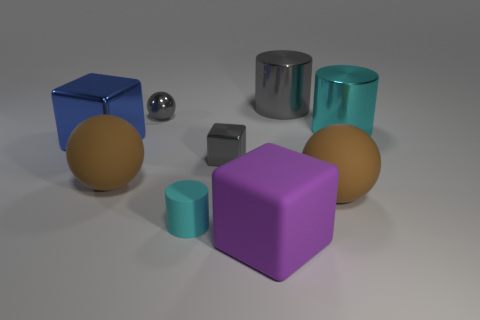What number of objects are small gray shiny objects in front of the big blue object or tiny purple shiny cubes?
Provide a short and direct response. 1. Does the large object behind the cyan metallic object have the same material as the large cyan object?
Give a very brief answer. Yes. Is the shape of the big gray metal thing the same as the small cyan matte thing?
Your answer should be very brief. Yes. What number of large matte objects are on the right side of the big cylinder left of the big cyan cylinder?
Your response must be concise. 1. There is a big cyan object that is the same shape as the big gray metallic object; what is it made of?
Keep it short and to the point. Metal. There is a small object that is behind the blue cube; does it have the same color as the tiny block?
Keep it short and to the point. Yes. Does the gray cylinder have the same material as the cyan cylinder that is on the right side of the rubber block?
Provide a short and direct response. Yes. There is a gray object in front of the blue block; what is its shape?
Keep it short and to the point. Cube. What number of other objects are there of the same material as the large purple cube?
Provide a short and direct response. 3. The gray ball is what size?
Offer a terse response. Small. 